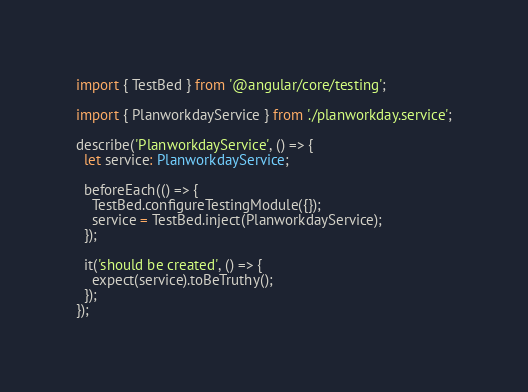<code> <loc_0><loc_0><loc_500><loc_500><_TypeScript_>import { TestBed } from '@angular/core/testing';

import { PlanworkdayService } from './planworkday.service';

describe('PlanworkdayService', () => {
  let service: PlanworkdayService;

  beforeEach(() => {
    TestBed.configureTestingModule({});
    service = TestBed.inject(PlanworkdayService);
  });

  it('should be created', () => {
    expect(service).toBeTruthy();
  });
});
</code> 